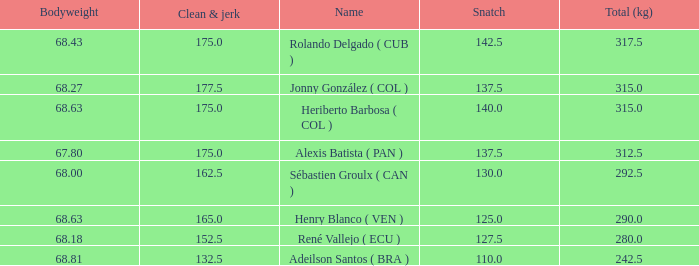Tell me the total number of snatches for clean and jerk more than 132.5 when the total kg was 315 and bodyweight was 68.63 1.0. 